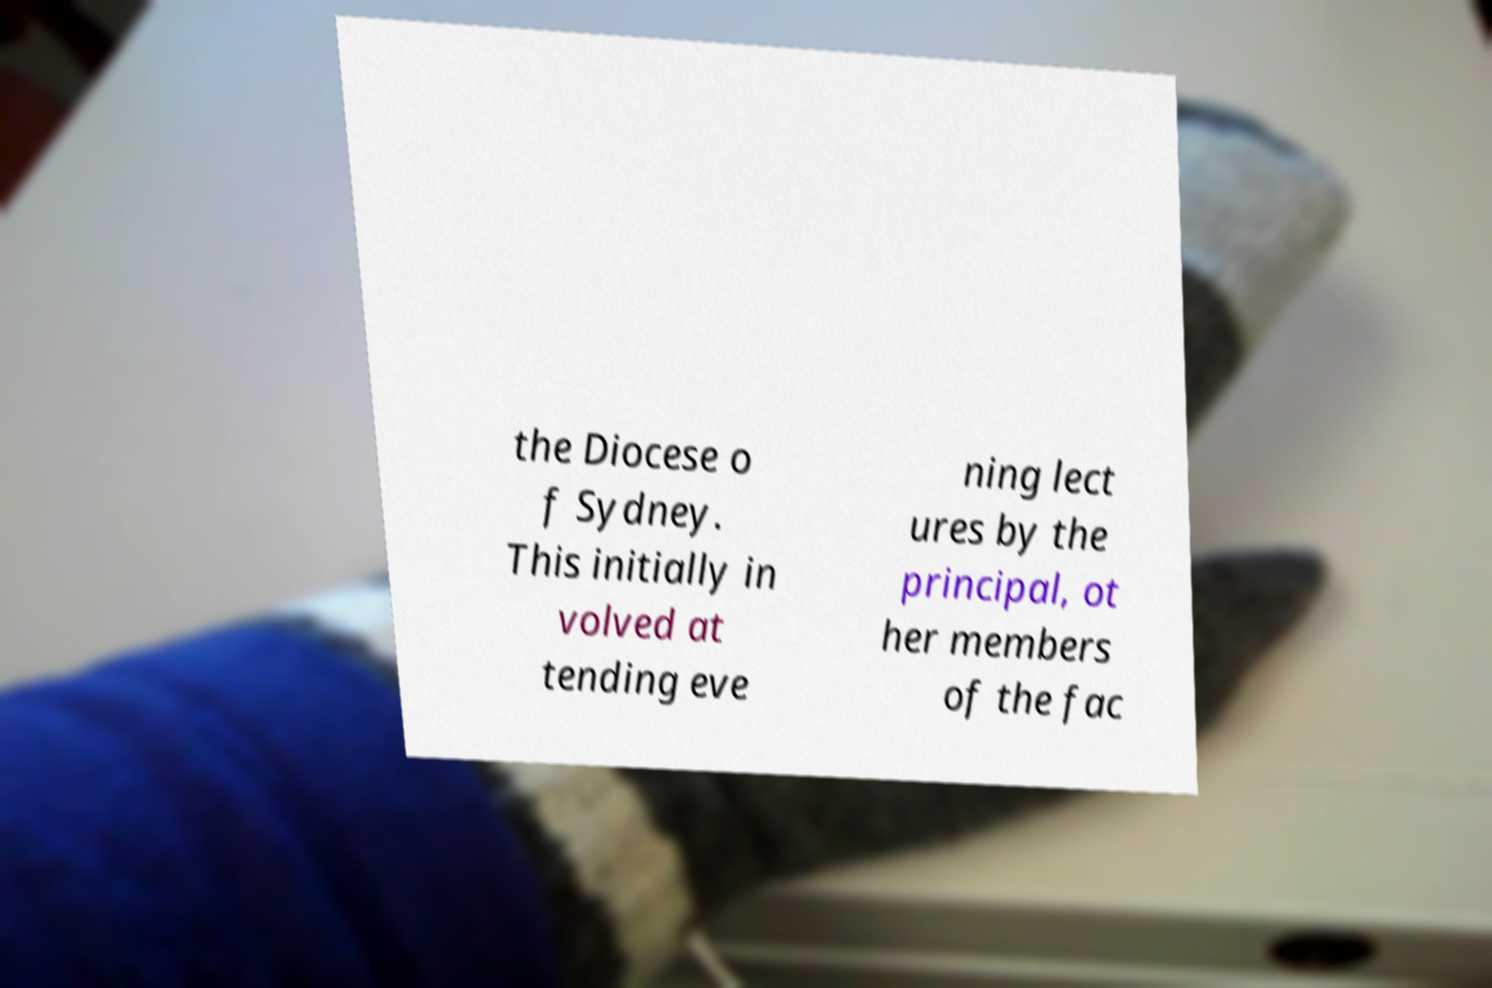Could you extract and type out the text from this image? the Diocese o f Sydney. This initially in volved at tending eve ning lect ures by the principal, ot her members of the fac 